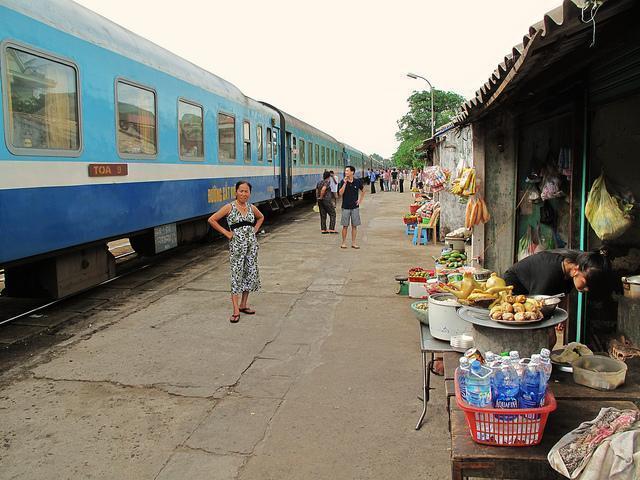What is the person on the right selling?
Answer the question by selecting the correct answer among the 4 following choices and explain your choice with a short sentence. The answer should be formatted with the following format: `Answer: choice
Rationale: rationale.`
Options: Pizza, water, cars, swords. Answer: water.
Rationale: The person has water bottles available for sale. 